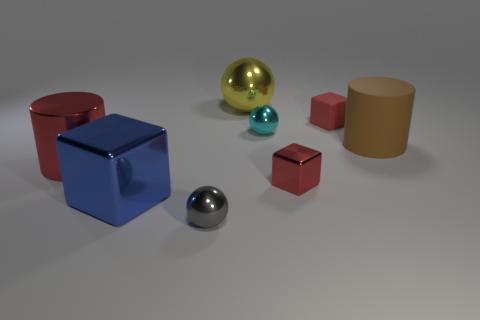Can you describe the positioning of the spheres in relation to the other objects? Certainly! There are three spheres. The large yellow sphere is positioned behind the blue metallic cube when facing the camera. A smaller turquoise sphere rests to the right of the yellow one and slightly behind it from this viewpoint. Finally, the silver sphere is located to the left and in front of the red metal block. 